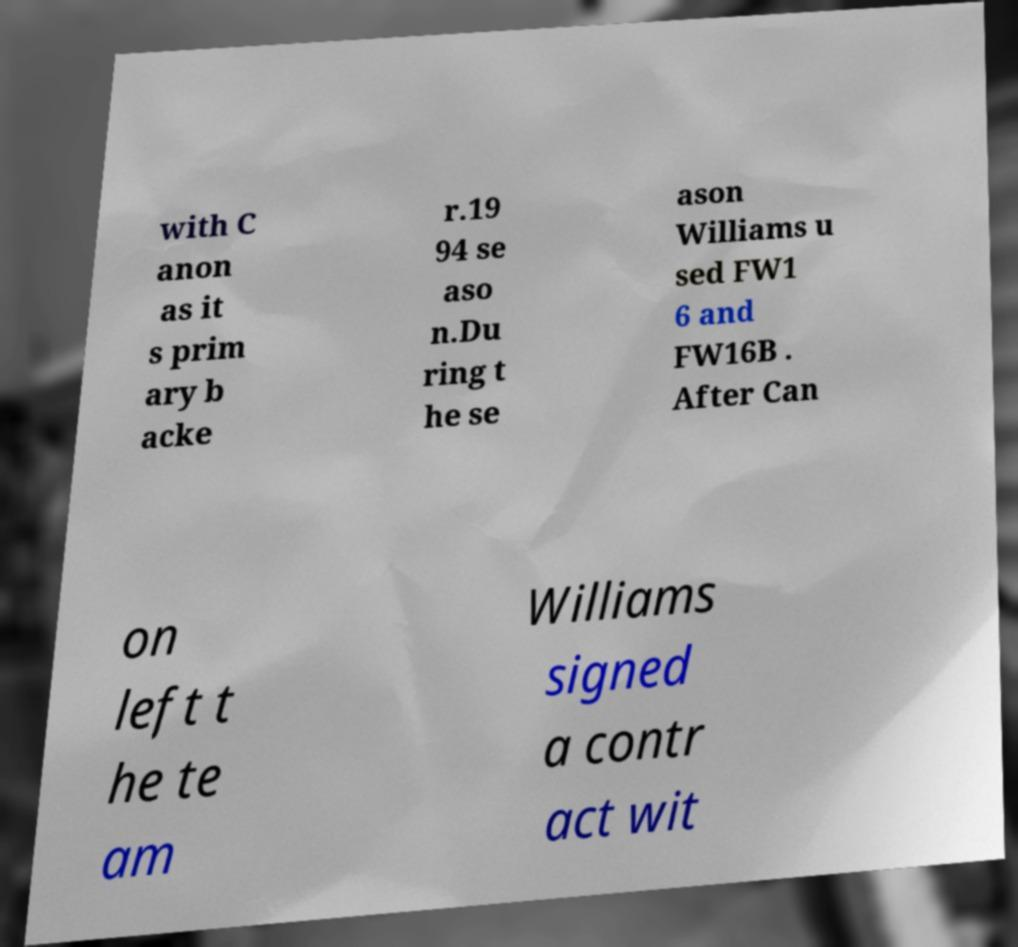Could you extract and type out the text from this image? with C anon as it s prim ary b acke r.19 94 se aso n.Du ring t he se ason Williams u sed FW1 6 and FW16B . After Can on left t he te am Williams signed a contr act wit 